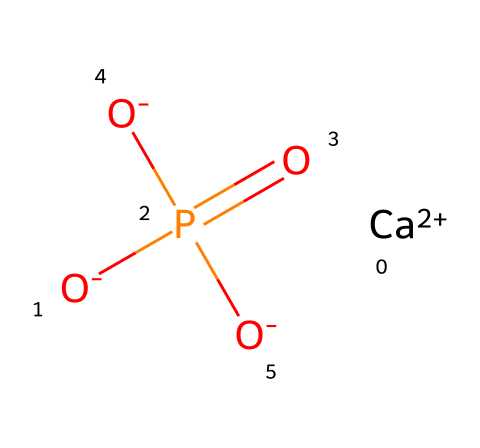what is the total number of oxygen atoms in this compound? The chemical structure has three negatively charged oxygen atoms, as indicated by three [O-] symbols, which represent oxygen atoms present. Therefore, the total count of oxygen atoms is three.
Answer: three what is the central atom in this molecule? The structure shows a phosphorus atom (P) connected to other atoms and is symbolic of phosphorus compounds, making it the central atom in this composition.
Answer: phosphorus how many calcium atoms are present? The molecular representation includes a singular calcium atom denoted by [Ca+2], indicating there is one calcium atom present in this compound.
Answer: one which type of compound is this? This compound is classified as a phosphate compound because it contains phosphate (the part with (O-)P(=O)([O-])[O-]), which is characterized by phosphorus and oxygen bonding.
Answer: phosphate how does calcium phosphate contribute to face paint? Calcium phosphate is known for its use as a pigment in face paint due to its ability to provide coverage and whiteness while being non-toxic, which makes it safe for cosmetic application.
Answer: pigment which bond denotes high reactivity in the molecule? The double bond between phosphorus and oxygen (P=O) signifies a high level of reactivity due to its electron-withdrawing characteristics, making it a reactive site in the molecule.
Answer: P=O 